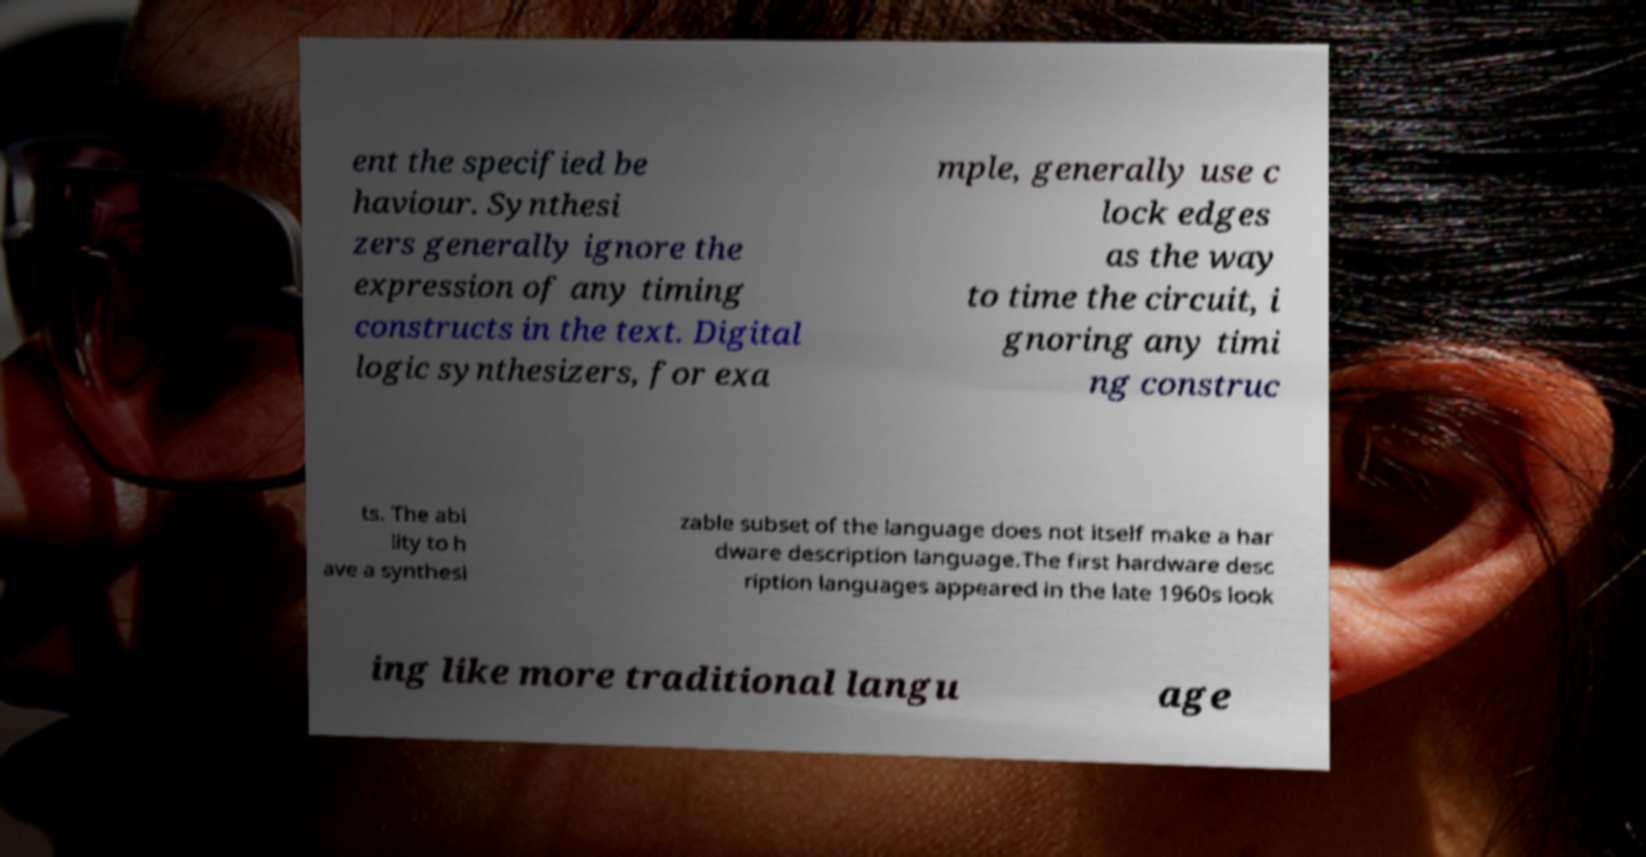Please read and relay the text visible in this image. What does it say? ent the specified be haviour. Synthesi zers generally ignore the expression of any timing constructs in the text. Digital logic synthesizers, for exa mple, generally use c lock edges as the way to time the circuit, i gnoring any timi ng construc ts. The abi lity to h ave a synthesi zable subset of the language does not itself make a har dware description language.The first hardware desc ription languages appeared in the late 1960s look ing like more traditional langu age 